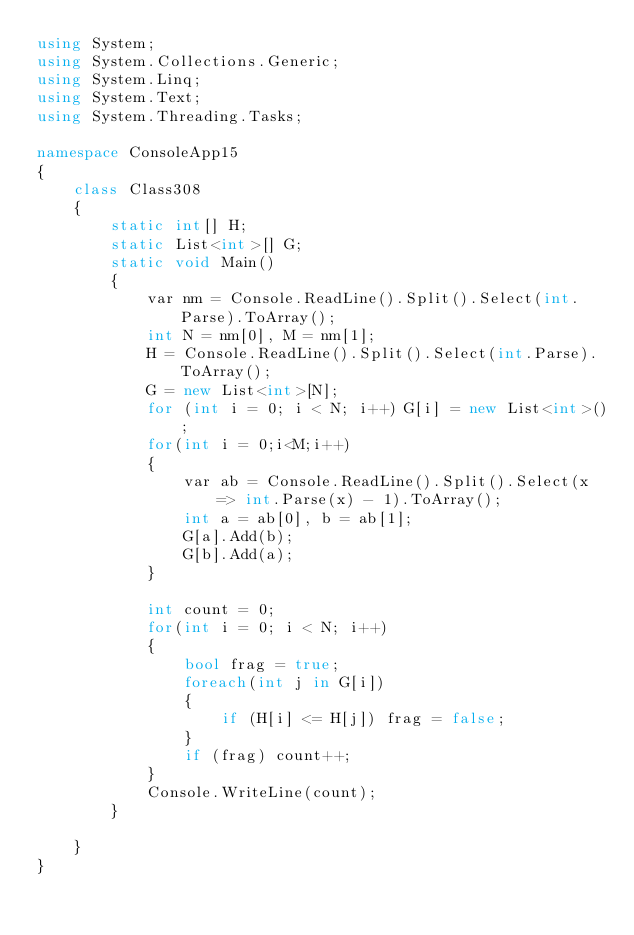<code> <loc_0><loc_0><loc_500><loc_500><_C#_>using System;
using System.Collections.Generic;
using System.Linq;
using System.Text;
using System.Threading.Tasks;

namespace ConsoleApp15
{
    class Class308
    {
        static int[] H;
        static List<int>[] G;
        static void Main()
        {
            var nm = Console.ReadLine().Split().Select(int.Parse).ToArray();
            int N = nm[0], M = nm[1];
            H = Console.ReadLine().Split().Select(int.Parse).ToArray();
            G = new List<int>[N];
            for (int i = 0; i < N; i++) G[i] = new List<int>();
            for(int i = 0;i<M;i++)
            {
                var ab = Console.ReadLine().Split().Select(x => int.Parse(x) - 1).ToArray();
                int a = ab[0], b = ab[1];
                G[a].Add(b);
                G[b].Add(a);
            }

            int count = 0;
            for(int i = 0; i < N; i++)
            {
                bool frag = true;
                foreach(int j in G[i])
                {
                    if (H[i] <= H[j]) frag = false;
                }
                if (frag) count++;
            }
            Console.WriteLine(count);
        }

    }
}
</code> 